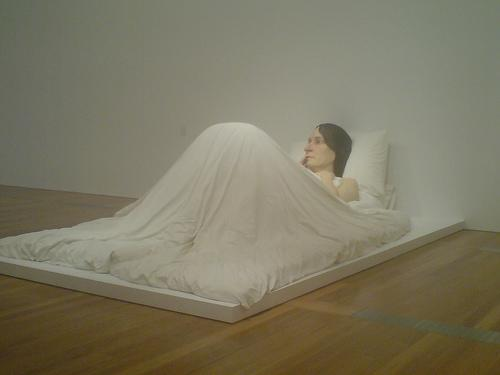What is the emotional sentiment evoked by the scene of the woman in the image? The image evokes a sense of peacefulness, relaxation, and tranquility, as the woman seems to be calmly resting in her cozy surroundings. Express the scene taking place in the image in a poetic manner. Amidst the soft folds of the blanket, the lady with the tresses of night finds solace, as she reclines upon a pillow, dreams weaving on a hardwood floor. Count the number of bedding-related objects in the image. There are ten bedding-related objects including various types of beds, blankets, sheets, a pillow, and a mattress. How many objects are located on the floor of the image? There are eight objects on the floor, including types of beds, wood floor sections, platform, and lines on the floor. Describe the woman's positioning in relation to the beds and floor. The woman is lying down on the floor, partially on a bed with her head on a pillow, surrounded by different sections of a hardwood floor, and covered by a blanket. Analyze the interaction of the woman with the surrounding objects. The woman is lying down and resting her head on a pillow, with a blanket on top of her, all set on a hardwood floor, which demonstrates a cozy and comfortable interaction. 